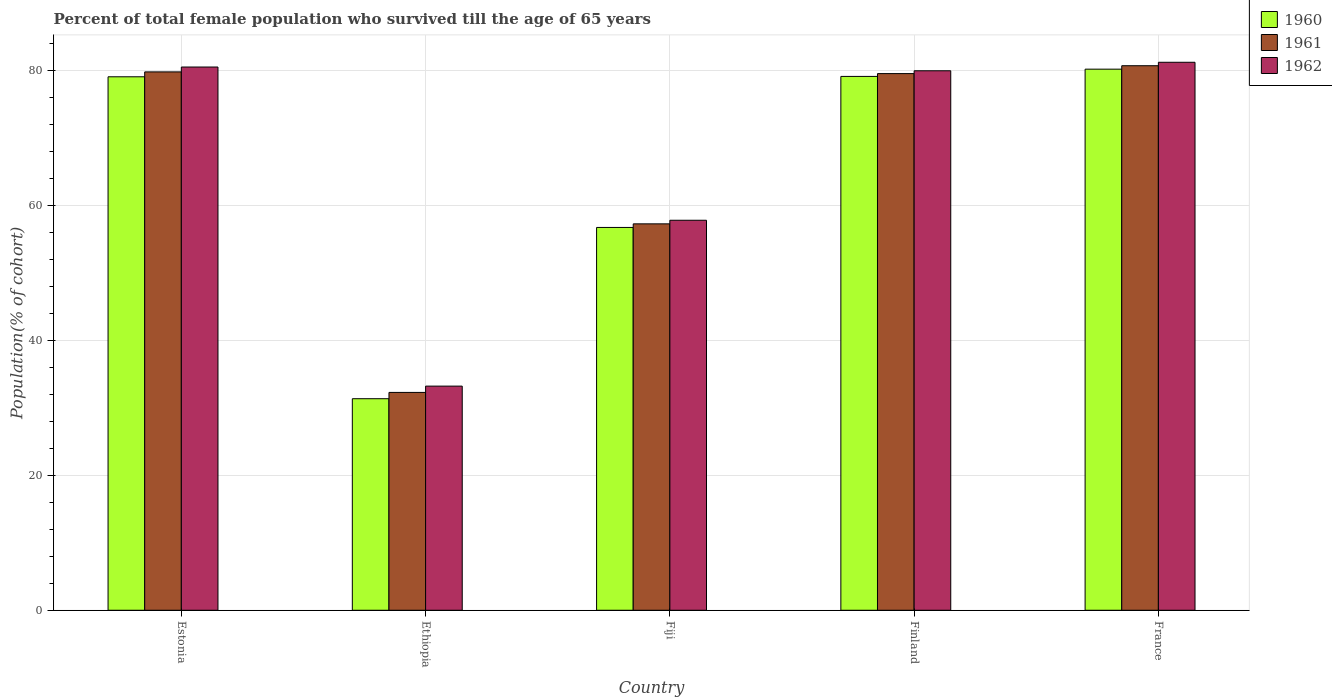How many groups of bars are there?
Provide a short and direct response. 5. How many bars are there on the 3rd tick from the left?
Provide a short and direct response. 3. What is the label of the 5th group of bars from the left?
Ensure brevity in your answer.  France. In how many cases, is the number of bars for a given country not equal to the number of legend labels?
Give a very brief answer. 0. What is the percentage of total female population who survived till the age of 65 years in 1960 in Estonia?
Your answer should be very brief. 79.08. Across all countries, what is the maximum percentage of total female population who survived till the age of 65 years in 1962?
Keep it short and to the point. 81.23. Across all countries, what is the minimum percentage of total female population who survived till the age of 65 years in 1961?
Your response must be concise. 32.29. In which country was the percentage of total female population who survived till the age of 65 years in 1962 maximum?
Ensure brevity in your answer.  France. In which country was the percentage of total female population who survived till the age of 65 years in 1961 minimum?
Ensure brevity in your answer.  Ethiopia. What is the total percentage of total female population who survived till the age of 65 years in 1960 in the graph?
Your answer should be very brief. 326.54. What is the difference between the percentage of total female population who survived till the age of 65 years in 1962 in Ethiopia and that in Finland?
Keep it short and to the point. -46.75. What is the difference between the percentage of total female population who survived till the age of 65 years in 1962 in Estonia and the percentage of total female population who survived till the age of 65 years in 1961 in Ethiopia?
Your answer should be compact. 48.24. What is the average percentage of total female population who survived till the age of 65 years in 1960 per country?
Offer a very short reply. 65.31. What is the difference between the percentage of total female population who survived till the age of 65 years of/in 1960 and percentage of total female population who survived till the age of 65 years of/in 1962 in Fiji?
Your answer should be very brief. -1.06. What is the ratio of the percentage of total female population who survived till the age of 65 years in 1961 in Estonia to that in Finland?
Offer a very short reply. 1. Is the percentage of total female population who survived till the age of 65 years in 1961 in Fiji less than that in Finland?
Make the answer very short. Yes. Is the difference between the percentage of total female population who survived till the age of 65 years in 1960 in Ethiopia and Finland greater than the difference between the percentage of total female population who survived till the age of 65 years in 1962 in Ethiopia and Finland?
Your answer should be compact. No. What is the difference between the highest and the second highest percentage of total female population who survived till the age of 65 years in 1960?
Make the answer very short. 1.13. What is the difference between the highest and the lowest percentage of total female population who survived till the age of 65 years in 1962?
Make the answer very short. 48.01. What does the 1st bar from the right in France represents?
Your answer should be compact. 1962. Is it the case that in every country, the sum of the percentage of total female population who survived till the age of 65 years in 1960 and percentage of total female population who survived till the age of 65 years in 1961 is greater than the percentage of total female population who survived till the age of 65 years in 1962?
Offer a very short reply. Yes. How many bars are there?
Offer a very short reply. 15. Are all the bars in the graph horizontal?
Your response must be concise. No. How many countries are there in the graph?
Ensure brevity in your answer.  5. Are the values on the major ticks of Y-axis written in scientific E-notation?
Your response must be concise. No. Does the graph contain any zero values?
Keep it short and to the point. No. Where does the legend appear in the graph?
Ensure brevity in your answer.  Top right. How are the legend labels stacked?
Give a very brief answer. Vertical. What is the title of the graph?
Ensure brevity in your answer.  Percent of total female population who survived till the age of 65 years. What is the label or title of the X-axis?
Your answer should be compact. Country. What is the label or title of the Y-axis?
Keep it short and to the point. Population(% of cohort). What is the Population(% of cohort) in 1960 in Estonia?
Give a very brief answer. 79.08. What is the Population(% of cohort) in 1961 in Estonia?
Your answer should be very brief. 79.81. What is the Population(% of cohort) of 1962 in Estonia?
Keep it short and to the point. 80.53. What is the Population(% of cohort) in 1960 in Ethiopia?
Ensure brevity in your answer.  31.36. What is the Population(% of cohort) of 1961 in Ethiopia?
Offer a very short reply. 32.29. What is the Population(% of cohort) in 1962 in Ethiopia?
Ensure brevity in your answer.  33.23. What is the Population(% of cohort) of 1960 in Fiji?
Keep it short and to the point. 56.75. What is the Population(% of cohort) in 1961 in Fiji?
Offer a terse response. 57.28. What is the Population(% of cohort) of 1962 in Fiji?
Ensure brevity in your answer.  57.81. What is the Population(% of cohort) in 1960 in Finland?
Keep it short and to the point. 79.14. What is the Population(% of cohort) of 1961 in Finland?
Your answer should be compact. 79.56. What is the Population(% of cohort) of 1962 in Finland?
Your response must be concise. 79.97. What is the Population(% of cohort) in 1960 in France?
Provide a succinct answer. 80.21. What is the Population(% of cohort) of 1961 in France?
Provide a short and direct response. 80.72. What is the Population(% of cohort) in 1962 in France?
Provide a short and direct response. 81.23. Across all countries, what is the maximum Population(% of cohort) in 1960?
Offer a very short reply. 80.21. Across all countries, what is the maximum Population(% of cohort) in 1961?
Offer a very short reply. 80.72. Across all countries, what is the maximum Population(% of cohort) of 1962?
Make the answer very short. 81.23. Across all countries, what is the minimum Population(% of cohort) of 1960?
Offer a terse response. 31.36. Across all countries, what is the minimum Population(% of cohort) in 1961?
Ensure brevity in your answer.  32.29. Across all countries, what is the minimum Population(% of cohort) in 1962?
Give a very brief answer. 33.23. What is the total Population(% of cohort) in 1960 in the graph?
Your answer should be very brief. 326.54. What is the total Population(% of cohort) in 1961 in the graph?
Your response must be concise. 329.66. What is the total Population(% of cohort) of 1962 in the graph?
Provide a succinct answer. 332.78. What is the difference between the Population(% of cohort) in 1960 in Estonia and that in Ethiopia?
Your answer should be very brief. 47.72. What is the difference between the Population(% of cohort) of 1961 in Estonia and that in Ethiopia?
Ensure brevity in your answer.  47.51. What is the difference between the Population(% of cohort) of 1962 in Estonia and that in Ethiopia?
Make the answer very short. 47.3. What is the difference between the Population(% of cohort) of 1960 in Estonia and that in Fiji?
Provide a succinct answer. 22.33. What is the difference between the Population(% of cohort) in 1961 in Estonia and that in Fiji?
Offer a very short reply. 22.52. What is the difference between the Population(% of cohort) in 1962 in Estonia and that in Fiji?
Keep it short and to the point. 22.72. What is the difference between the Population(% of cohort) of 1960 in Estonia and that in Finland?
Offer a terse response. -0.06. What is the difference between the Population(% of cohort) in 1961 in Estonia and that in Finland?
Provide a succinct answer. 0.25. What is the difference between the Population(% of cohort) in 1962 in Estonia and that in Finland?
Provide a short and direct response. 0.56. What is the difference between the Population(% of cohort) of 1960 in Estonia and that in France?
Offer a terse response. -1.13. What is the difference between the Population(% of cohort) in 1961 in Estonia and that in France?
Make the answer very short. -0.92. What is the difference between the Population(% of cohort) in 1962 in Estonia and that in France?
Your answer should be very brief. -0.7. What is the difference between the Population(% of cohort) of 1960 in Ethiopia and that in Fiji?
Provide a succinct answer. -25.39. What is the difference between the Population(% of cohort) of 1961 in Ethiopia and that in Fiji?
Your answer should be very brief. -24.99. What is the difference between the Population(% of cohort) in 1962 in Ethiopia and that in Fiji?
Ensure brevity in your answer.  -24.59. What is the difference between the Population(% of cohort) in 1960 in Ethiopia and that in Finland?
Your response must be concise. -47.78. What is the difference between the Population(% of cohort) in 1961 in Ethiopia and that in Finland?
Provide a short and direct response. -47.26. What is the difference between the Population(% of cohort) in 1962 in Ethiopia and that in Finland?
Make the answer very short. -46.75. What is the difference between the Population(% of cohort) of 1960 in Ethiopia and that in France?
Make the answer very short. -48.85. What is the difference between the Population(% of cohort) in 1961 in Ethiopia and that in France?
Offer a terse response. -48.43. What is the difference between the Population(% of cohort) of 1962 in Ethiopia and that in France?
Provide a succinct answer. -48.01. What is the difference between the Population(% of cohort) of 1960 in Fiji and that in Finland?
Make the answer very short. -22.39. What is the difference between the Population(% of cohort) in 1961 in Fiji and that in Finland?
Give a very brief answer. -22.27. What is the difference between the Population(% of cohort) of 1962 in Fiji and that in Finland?
Keep it short and to the point. -22.16. What is the difference between the Population(% of cohort) of 1960 in Fiji and that in France?
Your answer should be compact. -23.46. What is the difference between the Population(% of cohort) in 1961 in Fiji and that in France?
Ensure brevity in your answer.  -23.44. What is the difference between the Population(% of cohort) in 1962 in Fiji and that in France?
Make the answer very short. -23.42. What is the difference between the Population(% of cohort) in 1960 in Finland and that in France?
Provide a short and direct response. -1.07. What is the difference between the Population(% of cohort) in 1961 in Finland and that in France?
Provide a succinct answer. -1.17. What is the difference between the Population(% of cohort) of 1962 in Finland and that in France?
Keep it short and to the point. -1.26. What is the difference between the Population(% of cohort) in 1960 in Estonia and the Population(% of cohort) in 1961 in Ethiopia?
Offer a very short reply. 46.79. What is the difference between the Population(% of cohort) in 1960 in Estonia and the Population(% of cohort) in 1962 in Ethiopia?
Your answer should be compact. 45.86. What is the difference between the Population(% of cohort) in 1961 in Estonia and the Population(% of cohort) in 1962 in Ethiopia?
Make the answer very short. 46.58. What is the difference between the Population(% of cohort) of 1960 in Estonia and the Population(% of cohort) of 1961 in Fiji?
Your answer should be compact. 21.8. What is the difference between the Population(% of cohort) of 1960 in Estonia and the Population(% of cohort) of 1962 in Fiji?
Provide a succinct answer. 21.27. What is the difference between the Population(% of cohort) of 1961 in Estonia and the Population(% of cohort) of 1962 in Fiji?
Provide a short and direct response. 21.99. What is the difference between the Population(% of cohort) in 1960 in Estonia and the Population(% of cohort) in 1961 in Finland?
Offer a very short reply. -0.47. What is the difference between the Population(% of cohort) of 1960 in Estonia and the Population(% of cohort) of 1962 in Finland?
Provide a short and direct response. -0.89. What is the difference between the Population(% of cohort) of 1961 in Estonia and the Population(% of cohort) of 1962 in Finland?
Offer a terse response. -0.17. What is the difference between the Population(% of cohort) of 1960 in Estonia and the Population(% of cohort) of 1961 in France?
Your answer should be very brief. -1.64. What is the difference between the Population(% of cohort) of 1960 in Estonia and the Population(% of cohort) of 1962 in France?
Your answer should be very brief. -2.15. What is the difference between the Population(% of cohort) of 1961 in Estonia and the Population(% of cohort) of 1962 in France?
Give a very brief answer. -1.43. What is the difference between the Population(% of cohort) of 1960 in Ethiopia and the Population(% of cohort) of 1961 in Fiji?
Offer a terse response. -25.92. What is the difference between the Population(% of cohort) in 1960 in Ethiopia and the Population(% of cohort) in 1962 in Fiji?
Keep it short and to the point. -26.45. What is the difference between the Population(% of cohort) in 1961 in Ethiopia and the Population(% of cohort) in 1962 in Fiji?
Offer a terse response. -25.52. What is the difference between the Population(% of cohort) of 1960 in Ethiopia and the Population(% of cohort) of 1961 in Finland?
Ensure brevity in your answer.  -48.2. What is the difference between the Population(% of cohort) of 1960 in Ethiopia and the Population(% of cohort) of 1962 in Finland?
Offer a very short reply. -48.61. What is the difference between the Population(% of cohort) of 1961 in Ethiopia and the Population(% of cohort) of 1962 in Finland?
Provide a succinct answer. -47.68. What is the difference between the Population(% of cohort) of 1960 in Ethiopia and the Population(% of cohort) of 1961 in France?
Offer a terse response. -49.36. What is the difference between the Population(% of cohort) of 1960 in Ethiopia and the Population(% of cohort) of 1962 in France?
Keep it short and to the point. -49.88. What is the difference between the Population(% of cohort) of 1961 in Ethiopia and the Population(% of cohort) of 1962 in France?
Provide a short and direct response. -48.94. What is the difference between the Population(% of cohort) of 1960 in Fiji and the Population(% of cohort) of 1961 in Finland?
Ensure brevity in your answer.  -22.81. What is the difference between the Population(% of cohort) in 1960 in Fiji and the Population(% of cohort) in 1962 in Finland?
Offer a terse response. -23.22. What is the difference between the Population(% of cohort) in 1961 in Fiji and the Population(% of cohort) in 1962 in Finland?
Keep it short and to the point. -22.69. What is the difference between the Population(% of cohort) of 1960 in Fiji and the Population(% of cohort) of 1961 in France?
Provide a short and direct response. -23.97. What is the difference between the Population(% of cohort) in 1960 in Fiji and the Population(% of cohort) in 1962 in France?
Provide a short and direct response. -24.49. What is the difference between the Population(% of cohort) of 1961 in Fiji and the Population(% of cohort) of 1962 in France?
Offer a very short reply. -23.95. What is the difference between the Population(% of cohort) in 1960 in Finland and the Population(% of cohort) in 1961 in France?
Give a very brief answer. -1.59. What is the difference between the Population(% of cohort) in 1960 in Finland and the Population(% of cohort) in 1962 in France?
Your answer should be compact. -2.1. What is the difference between the Population(% of cohort) of 1961 in Finland and the Population(% of cohort) of 1962 in France?
Provide a short and direct response. -1.68. What is the average Population(% of cohort) of 1960 per country?
Keep it short and to the point. 65.31. What is the average Population(% of cohort) in 1961 per country?
Make the answer very short. 65.93. What is the average Population(% of cohort) of 1962 per country?
Provide a short and direct response. 66.56. What is the difference between the Population(% of cohort) in 1960 and Population(% of cohort) in 1961 in Estonia?
Offer a very short reply. -0.72. What is the difference between the Population(% of cohort) in 1960 and Population(% of cohort) in 1962 in Estonia?
Your answer should be very brief. -1.45. What is the difference between the Population(% of cohort) of 1961 and Population(% of cohort) of 1962 in Estonia?
Your response must be concise. -0.72. What is the difference between the Population(% of cohort) of 1960 and Population(% of cohort) of 1961 in Ethiopia?
Offer a terse response. -0.93. What is the difference between the Population(% of cohort) of 1960 and Population(% of cohort) of 1962 in Ethiopia?
Ensure brevity in your answer.  -1.87. What is the difference between the Population(% of cohort) of 1961 and Population(% of cohort) of 1962 in Ethiopia?
Your answer should be compact. -0.93. What is the difference between the Population(% of cohort) in 1960 and Population(% of cohort) in 1961 in Fiji?
Offer a terse response. -0.53. What is the difference between the Population(% of cohort) in 1960 and Population(% of cohort) in 1962 in Fiji?
Your answer should be very brief. -1.06. What is the difference between the Population(% of cohort) in 1961 and Population(% of cohort) in 1962 in Fiji?
Your answer should be very brief. -0.53. What is the difference between the Population(% of cohort) in 1960 and Population(% of cohort) in 1961 in Finland?
Give a very brief answer. -0.42. What is the difference between the Population(% of cohort) in 1960 and Population(% of cohort) in 1962 in Finland?
Your response must be concise. -0.84. What is the difference between the Population(% of cohort) in 1961 and Population(% of cohort) in 1962 in Finland?
Provide a succinct answer. -0.42. What is the difference between the Population(% of cohort) in 1960 and Population(% of cohort) in 1961 in France?
Offer a terse response. -0.51. What is the difference between the Population(% of cohort) of 1960 and Population(% of cohort) of 1962 in France?
Provide a succinct answer. -1.02. What is the difference between the Population(% of cohort) in 1961 and Population(% of cohort) in 1962 in France?
Offer a terse response. -0.51. What is the ratio of the Population(% of cohort) in 1960 in Estonia to that in Ethiopia?
Your answer should be compact. 2.52. What is the ratio of the Population(% of cohort) in 1961 in Estonia to that in Ethiopia?
Make the answer very short. 2.47. What is the ratio of the Population(% of cohort) of 1962 in Estonia to that in Ethiopia?
Your response must be concise. 2.42. What is the ratio of the Population(% of cohort) in 1960 in Estonia to that in Fiji?
Keep it short and to the point. 1.39. What is the ratio of the Population(% of cohort) of 1961 in Estonia to that in Fiji?
Provide a succinct answer. 1.39. What is the ratio of the Population(% of cohort) in 1962 in Estonia to that in Fiji?
Make the answer very short. 1.39. What is the ratio of the Population(% of cohort) of 1960 in Estonia to that in Finland?
Give a very brief answer. 1. What is the ratio of the Population(% of cohort) in 1961 in Estonia to that in Finland?
Offer a very short reply. 1. What is the ratio of the Population(% of cohort) of 1962 in Estonia to that in Finland?
Provide a succinct answer. 1.01. What is the ratio of the Population(% of cohort) of 1960 in Estonia to that in France?
Ensure brevity in your answer.  0.99. What is the ratio of the Population(% of cohort) of 1962 in Estonia to that in France?
Provide a succinct answer. 0.99. What is the ratio of the Population(% of cohort) of 1960 in Ethiopia to that in Fiji?
Your answer should be very brief. 0.55. What is the ratio of the Population(% of cohort) in 1961 in Ethiopia to that in Fiji?
Give a very brief answer. 0.56. What is the ratio of the Population(% of cohort) in 1962 in Ethiopia to that in Fiji?
Your answer should be very brief. 0.57. What is the ratio of the Population(% of cohort) in 1960 in Ethiopia to that in Finland?
Offer a terse response. 0.4. What is the ratio of the Population(% of cohort) in 1961 in Ethiopia to that in Finland?
Give a very brief answer. 0.41. What is the ratio of the Population(% of cohort) in 1962 in Ethiopia to that in Finland?
Your response must be concise. 0.42. What is the ratio of the Population(% of cohort) in 1960 in Ethiopia to that in France?
Offer a terse response. 0.39. What is the ratio of the Population(% of cohort) of 1962 in Ethiopia to that in France?
Offer a very short reply. 0.41. What is the ratio of the Population(% of cohort) in 1960 in Fiji to that in Finland?
Provide a short and direct response. 0.72. What is the ratio of the Population(% of cohort) of 1961 in Fiji to that in Finland?
Keep it short and to the point. 0.72. What is the ratio of the Population(% of cohort) in 1962 in Fiji to that in Finland?
Offer a very short reply. 0.72. What is the ratio of the Population(% of cohort) in 1960 in Fiji to that in France?
Offer a terse response. 0.71. What is the ratio of the Population(% of cohort) in 1961 in Fiji to that in France?
Offer a very short reply. 0.71. What is the ratio of the Population(% of cohort) of 1962 in Fiji to that in France?
Your answer should be very brief. 0.71. What is the ratio of the Population(% of cohort) in 1960 in Finland to that in France?
Your response must be concise. 0.99. What is the ratio of the Population(% of cohort) in 1961 in Finland to that in France?
Offer a very short reply. 0.99. What is the ratio of the Population(% of cohort) in 1962 in Finland to that in France?
Your answer should be compact. 0.98. What is the difference between the highest and the second highest Population(% of cohort) of 1960?
Give a very brief answer. 1.07. What is the difference between the highest and the second highest Population(% of cohort) in 1961?
Your answer should be compact. 0.92. What is the difference between the highest and the second highest Population(% of cohort) of 1962?
Your response must be concise. 0.7. What is the difference between the highest and the lowest Population(% of cohort) of 1960?
Provide a succinct answer. 48.85. What is the difference between the highest and the lowest Population(% of cohort) of 1961?
Keep it short and to the point. 48.43. What is the difference between the highest and the lowest Population(% of cohort) of 1962?
Keep it short and to the point. 48.01. 